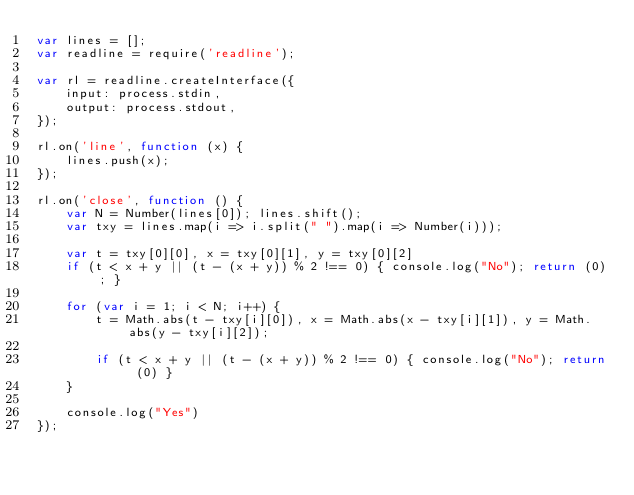Convert code to text. <code><loc_0><loc_0><loc_500><loc_500><_JavaScript_>var lines = [];
var readline = require('readline');

var rl = readline.createInterface({
    input: process.stdin,
    output: process.stdout,
});

rl.on('line', function (x) {
    lines.push(x);
});

rl.on('close', function () {
    var N = Number(lines[0]); lines.shift();
    var txy = lines.map(i => i.split(" ").map(i => Number(i)));

    var t = txy[0][0], x = txy[0][1], y = txy[0][2]
    if (t < x + y || (t - (x + y)) % 2 !== 0) { console.log("No"); return (0); }

    for (var i = 1; i < N; i++) {
        t = Math.abs(t - txy[i][0]), x = Math.abs(x - txy[i][1]), y = Math.abs(y - txy[i][2]);

        if (t < x + y || (t - (x + y)) % 2 !== 0) { console.log("No"); return (0) }
    }

    console.log("Yes")
});
</code> 